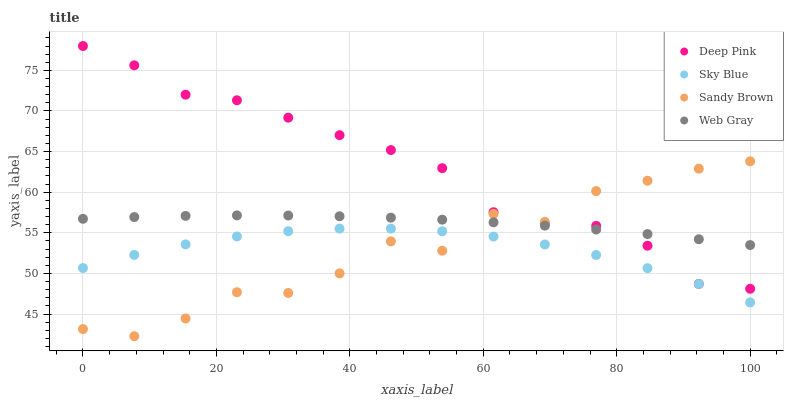Does Sky Blue have the minimum area under the curve?
Answer yes or no. Yes. Does Deep Pink have the maximum area under the curve?
Answer yes or no. Yes. Does Deep Pink have the minimum area under the curve?
Answer yes or no. No. Does Sky Blue have the maximum area under the curve?
Answer yes or no. No. Is Web Gray the smoothest?
Answer yes or no. Yes. Is Sandy Brown the roughest?
Answer yes or no. Yes. Is Sky Blue the smoothest?
Answer yes or no. No. Is Sky Blue the roughest?
Answer yes or no. No. Does Sandy Brown have the lowest value?
Answer yes or no. Yes. Does Sky Blue have the lowest value?
Answer yes or no. No. Does Deep Pink have the highest value?
Answer yes or no. Yes. Does Sky Blue have the highest value?
Answer yes or no. No. Is Sky Blue less than Deep Pink?
Answer yes or no. Yes. Is Web Gray greater than Sky Blue?
Answer yes or no. Yes. Does Web Gray intersect Deep Pink?
Answer yes or no. Yes. Is Web Gray less than Deep Pink?
Answer yes or no. No. Is Web Gray greater than Deep Pink?
Answer yes or no. No. Does Sky Blue intersect Deep Pink?
Answer yes or no. No. 